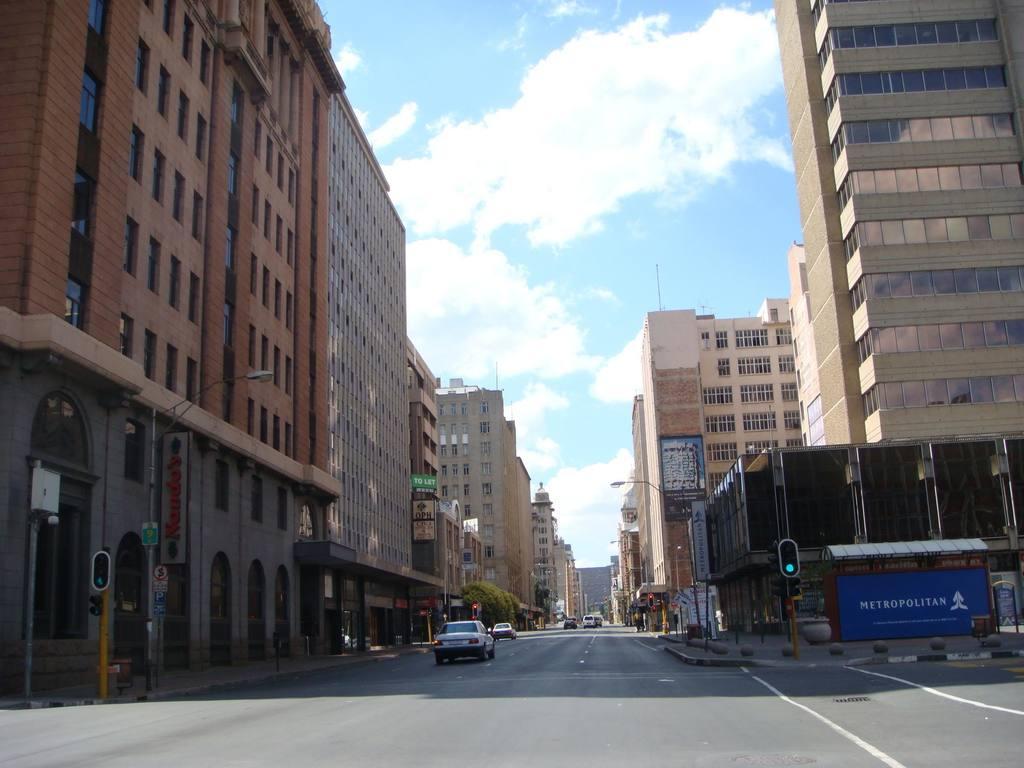How would you summarize this image in a sentence or two? This picture consists of building visible on the right side and on the left side , in the middle there is a road , on the road I can see vehicles and poles and sign boards and the sky visible at the top and a blue color board visible in front of the building on the right side. 